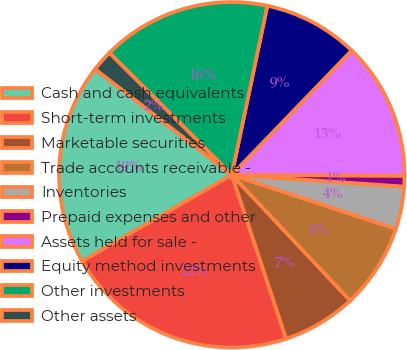Convert chart. <chart><loc_0><loc_0><loc_500><loc_500><pie_chart><fcel>Cash and cash equivalents<fcel>Short-term investments<fcel>Marketable securities<fcel>Trade accounts receivable -<fcel>Inventories<fcel>Prepaid expenses and other<fcel>Assets held for sale -<fcel>Equity method investments<fcel>Other investments<fcel>Other assets<nl><fcel>18.8%<fcel>21.77%<fcel>6.93%<fcel>7.92%<fcel>3.97%<fcel>1.0%<fcel>12.87%<fcel>8.91%<fcel>15.83%<fcel>1.99%<nl></chart> 